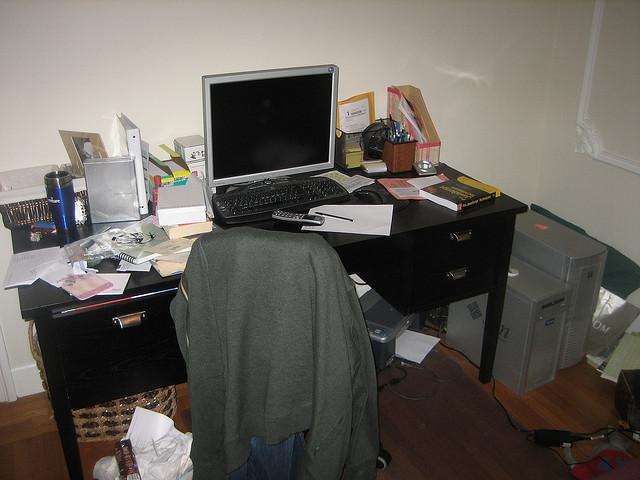What is in the room? computer 